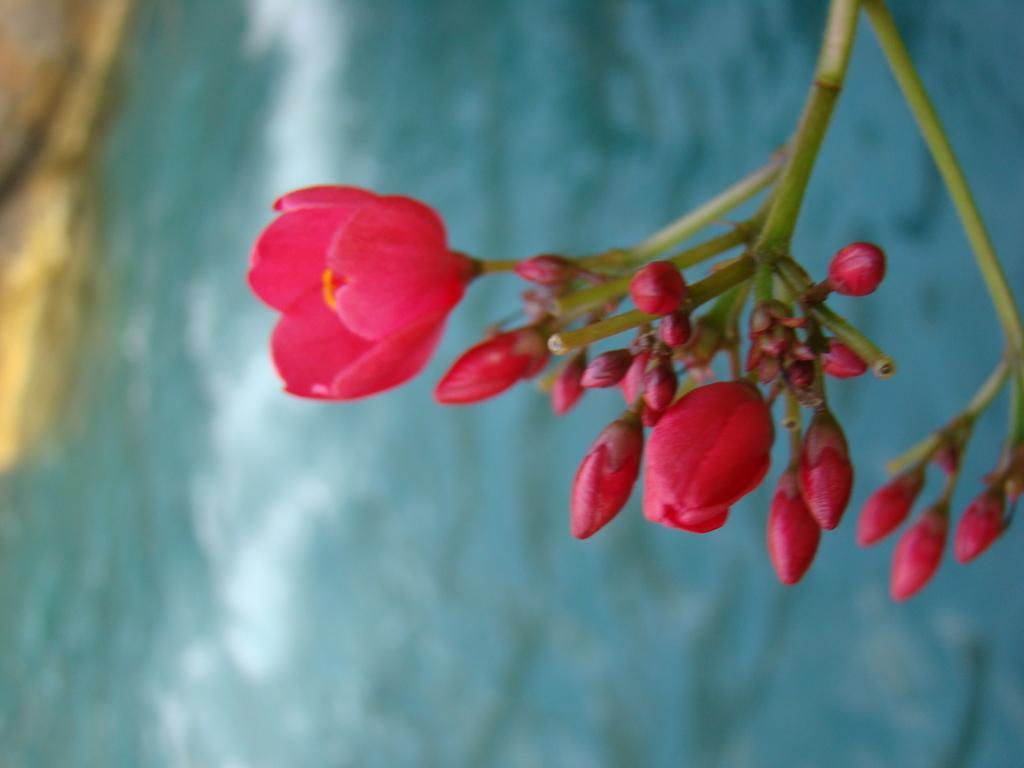Describe this image in one or two sentences. In this image we can see a plant. There are many flowers and buds to a plant. There is a lake in the image. There is a rock at the left side of the image. 